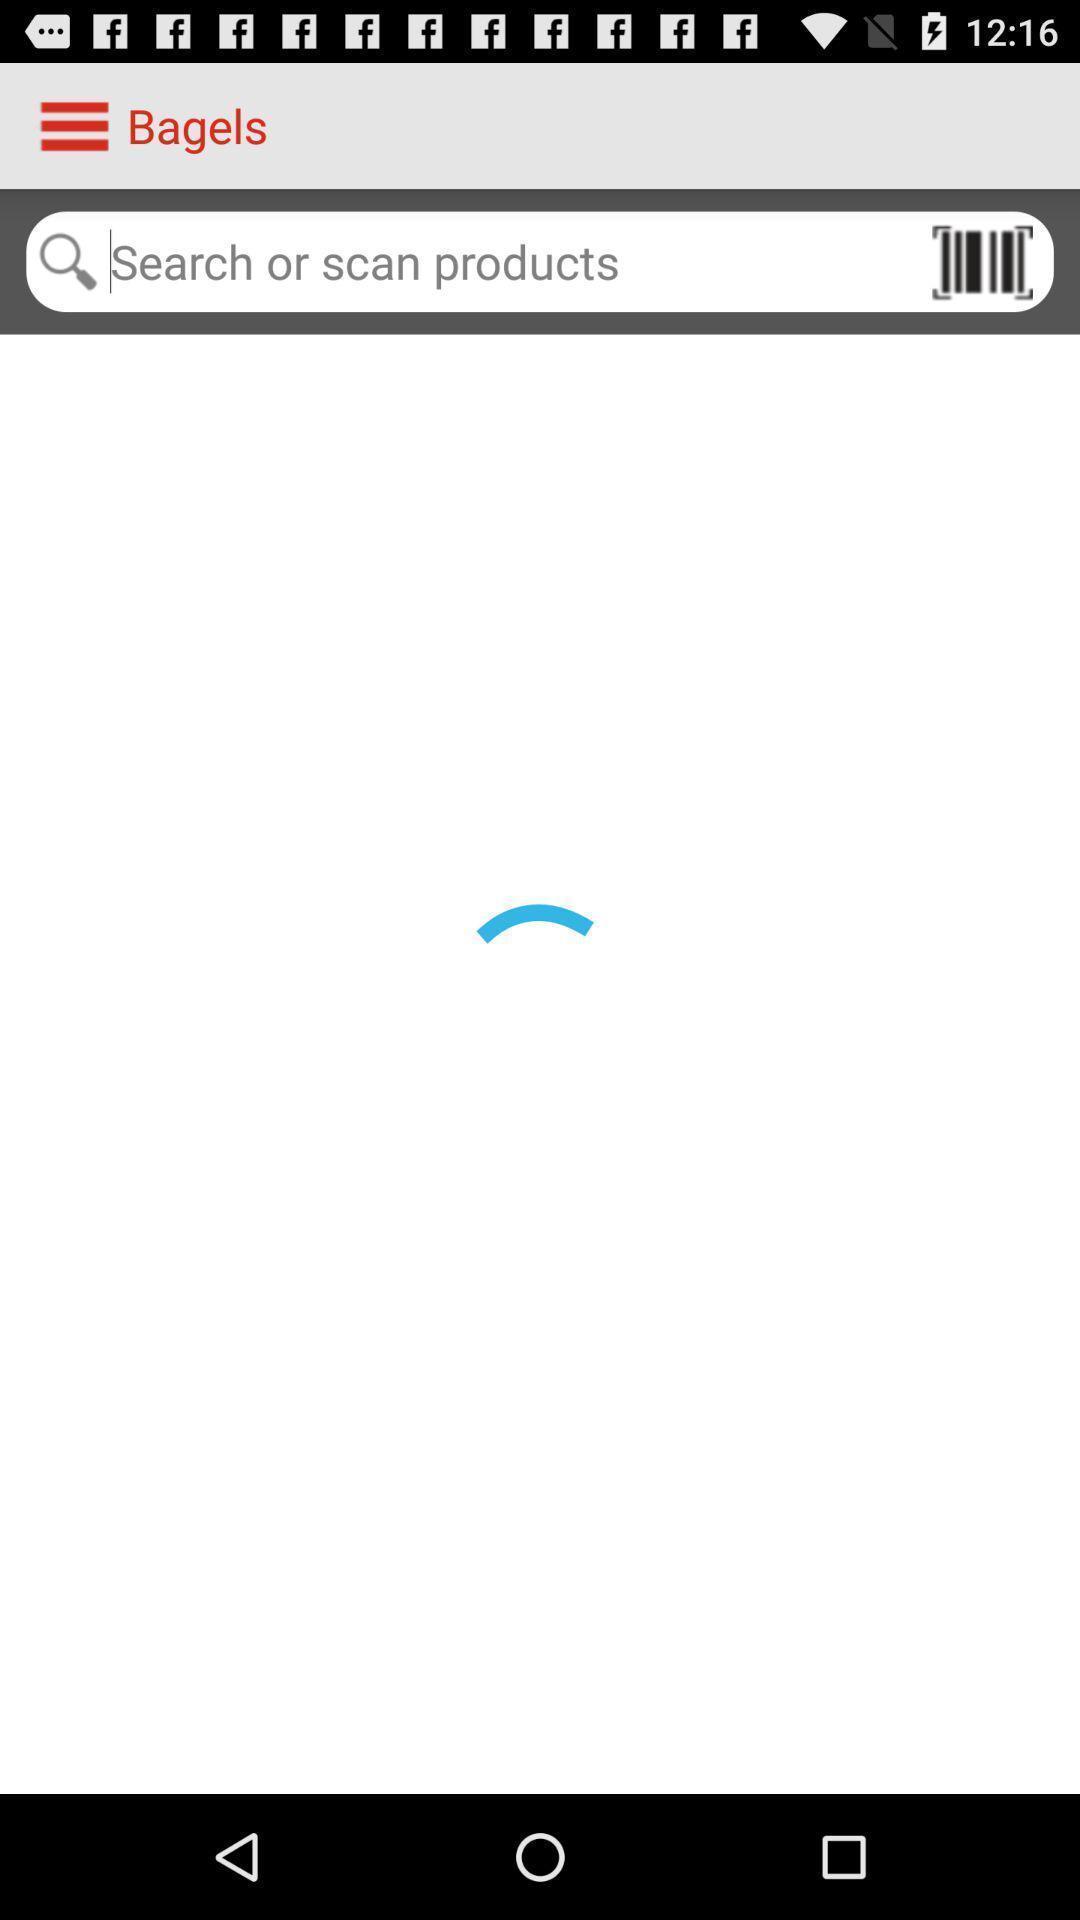Describe the key features of this screenshot. Search bar to search or scan for products in app. 